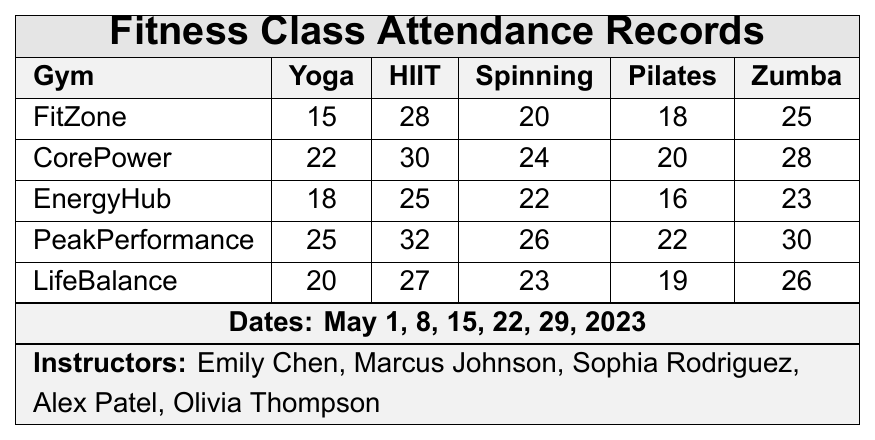What is the total attendance for Yoga classes across all gyms? To find the total attendance for Yoga classes, I will sum the attendance values for Yoga from each gym: 15 (FitZone) + 22 (CorePower) + 18 (EnergyHub) + 25 (PeakPerformance) + 20 (LifeBalance) = 100.
Answer: 100 Which gym had the highest attendance for HIIT classes? I need to look at the HIIT attendance values for each gym: 28 (FitZone), 30 (CorePower), 25 (EnergyHub), 32 (PeakPerformance), and 27 (LifeBalance). The highest value is 32, which corresponds to PeakPerformance.
Answer: PeakPerformance What is the average attendance for Spinning classes across all gyms? To calculate the average, I will sum the Spinning class attendances: 20 (FitZone) + 24 (CorePower) + 22 (EnergyHub) + 26 (PeakPerformance) + 23 (LifeBalance) = 115. Then, divide by the number of gyms (5): 115 / 5 = 23.
Answer: 23 Did any gym have less than 20 attendees for Pilates classes? Looking at the Pilates attendance values: 18 (FitZone), 20 (CorePower), 16 (EnergyHub), 22 (PeakPerformance), and 19 (LifeBalance), EnergyHub had 16 attendees, which is less than 20.
Answer: Yes What is the difference between the highest and lowest attendance for Zumba classes? The highest attendance for Zumba is 30 (PeakPerformance) and the lowest is 25 (FitZone). Thus, the difference is 30 - 25 = 5.
Answer: 5 Which instructor is associated with the fifth gym, LifeBalance? The table states that the instructors are: Emily Chen, Marcus Johnson, Sophia Rodriguez, Alex Patel, and Olivia Thompson. LifeBalance is the fifth gym, and its instructor is Olivia Thompson.
Answer: Olivia Thompson What is the total attendance for all classes at CorePower? The total attendance for CorePower can be calculated by summing all class attendances: 22 (Yoga) + 30 (HIIT) + 24 (Spinning) + 20 (Pilates) + 28 (Zumba) = 124.
Answer: 124 How many more attendees did PeakPerformance have for HIIT compared to FitZone? The HIIT attendance for PeakPerformance is 32 and for FitZone is 28. The difference is 32 - 28 = 4 more attendees at PeakPerformance.
Answer: 4 Which class has the lowest average attendance across all gyms? First, I will calculate the average for each class: Yoga (100/5=20), HIIT (142/5=28.4), Spinning (115/5=23), Pilates (95/5=19), Zumba (134/5=26.8). The minimum average is for Pilates, with an average of 19.
Answer: Pilates Did CorePower have higher attendance for Zumba than EnergyHub? The attendance for Zumba at CorePower is 28 while at EnergyHub it’s 23. Since 28 is greater than 23, the answer is yes.
Answer: Yes 